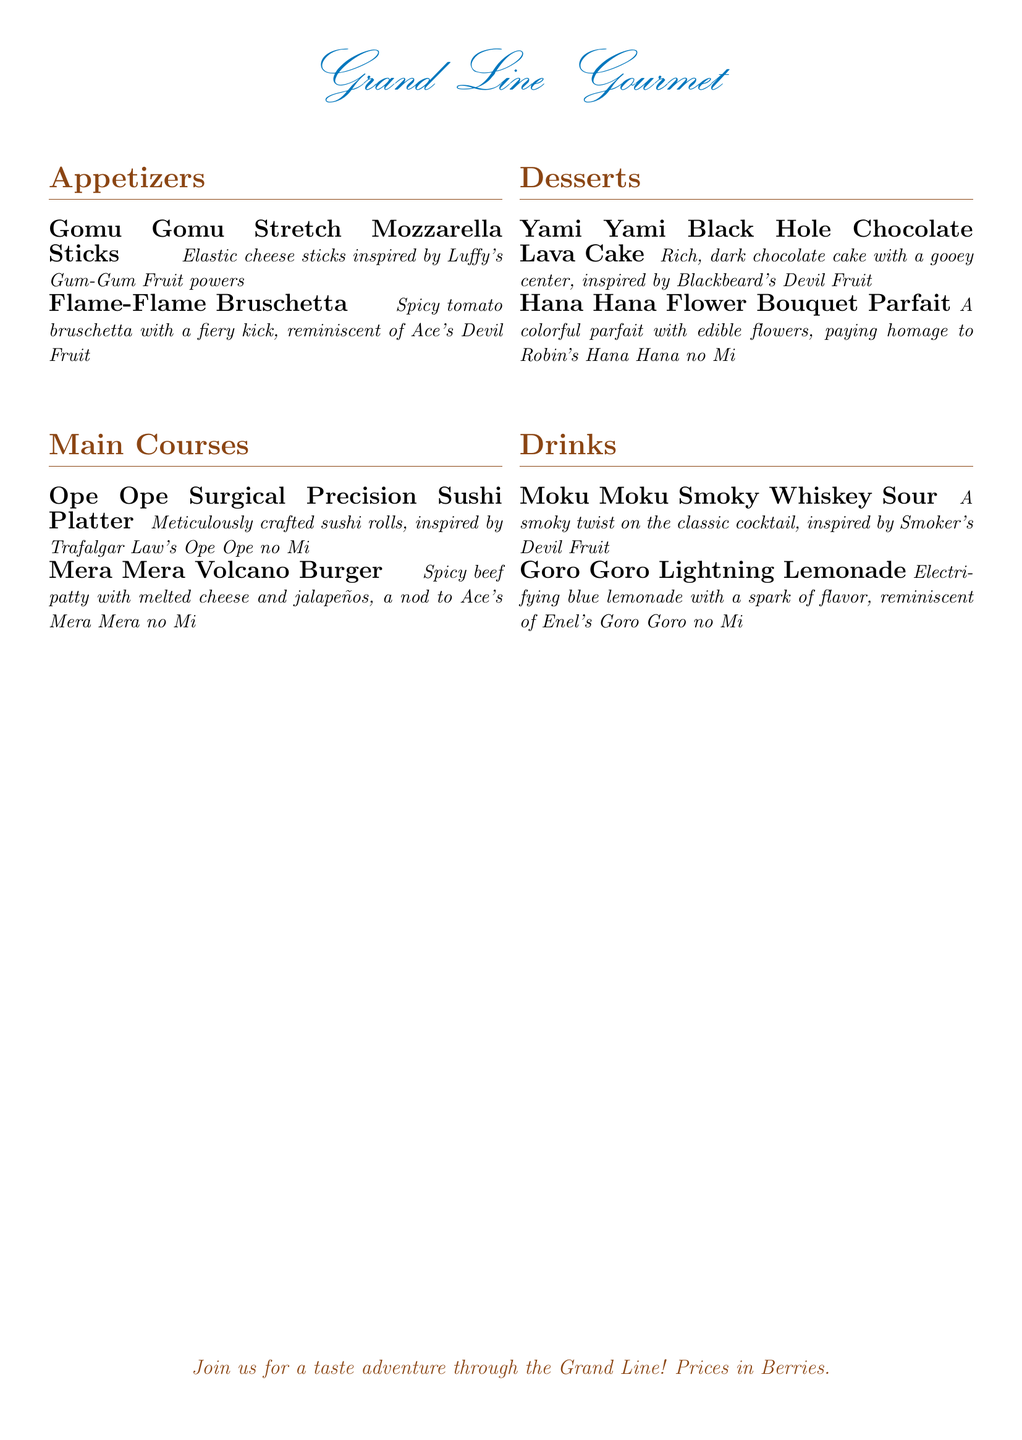What is the name of the dessert inspired by Blackbeard's Devil Fruit? The dessert inspired by Blackbeard's Devil Fruit is listed under the desserts section of the menu, which is the Yami Yami Black Hole Chocolate Lava Cake.
Answer: Yami Yami Black Hole Chocolate Lava Cake How many main courses are listed in the menu? The main courses are counted by identifying each listed item under the main courses section, and there are two items mentioned.
Answer: 2 What is the drink that is inspired by Smoker's Devil Fruit? The drink referencing Smoker's Devil Fruit is mentioned in the drinks section, which is the Moku Moku Smoky Whiskey Sour.
Answer: Moku Moku Smoky Whiskey Sour Which appetizer is inspired by Luffy's Gum-Gum Fruit? The appetizer that draws inspiration from Luffy's Gum-Gum Fruit is identified in the appetizers section as the Gomu Gomu Stretch Mozzarella Sticks.
Answer: Gomu Gomu Stretch Mozzarella Sticks What is the flavor profile of the Mera Mera Volcano Burger? The Mera Mera Volcano Burger is described with specific ingredients to suggest its flavor, which include spicy beef patty with melted cheese and jalapeños.
Answer: Spicy What is the title of the menu? The title of the menu is prominently displayed at the beginning of the document, which is Grand Line Gourmet.
Answer: Grand Line Gourmet What type of beverage is Goro Goro Lightning Lemonade? The drink Goro Goro Lightning Lemonade is categorized under the drinks section, indicated as an electrifying beverage.
Answer: Lemonade How many desserts are mentioned in this menu? The desserts are counted from the desserts section, which shows there are two listed items.
Answer: 2 What is the theme of the menu? The theme of the menu is indicated through the naming of the dishes and drinks, which are all inspired by Devil Fruits from One Piece.
Answer: Devil Fruit-inspired 